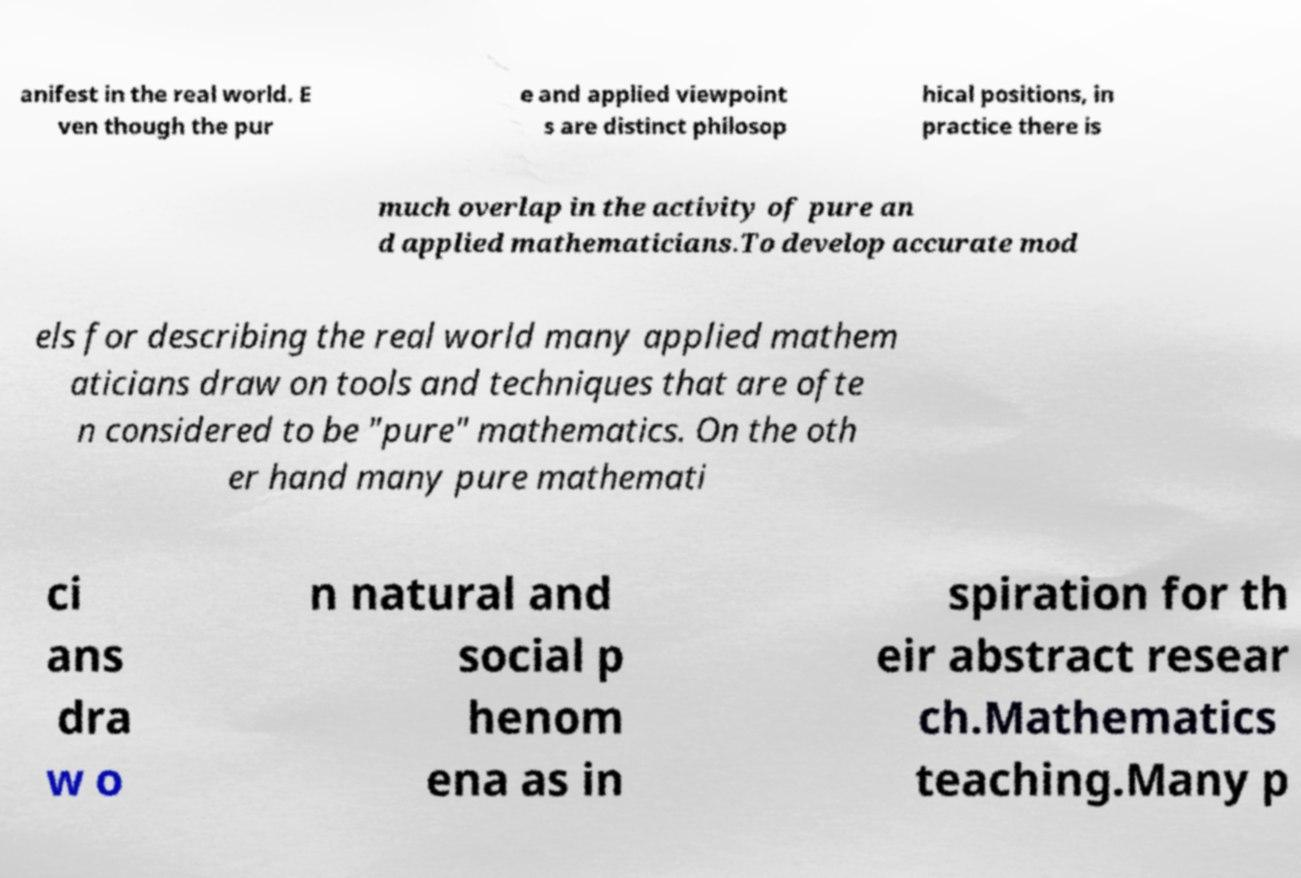Could you assist in decoding the text presented in this image and type it out clearly? anifest in the real world. E ven though the pur e and applied viewpoint s are distinct philosop hical positions, in practice there is much overlap in the activity of pure an d applied mathematicians.To develop accurate mod els for describing the real world many applied mathem aticians draw on tools and techniques that are ofte n considered to be "pure" mathematics. On the oth er hand many pure mathemati ci ans dra w o n natural and social p henom ena as in spiration for th eir abstract resear ch.Mathematics teaching.Many p 